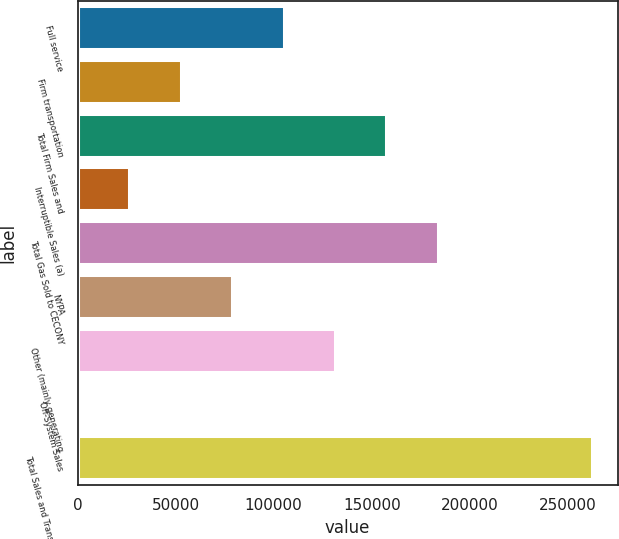<chart> <loc_0><loc_0><loc_500><loc_500><bar_chart><fcel>Full service<fcel>Firm transportation<fcel>Total Firm Sales and<fcel>Interruptible Sales (a)<fcel>Total Gas Sold to CECONY<fcel>NYPA<fcel>Other (mainly generating<fcel>Off-System Sales<fcel>Total Sales and Transportation<nl><fcel>105029<fcel>52591.6<fcel>157467<fcel>26372.8<fcel>183686<fcel>78810.4<fcel>131248<fcel>154<fcel>262342<nl></chart> 